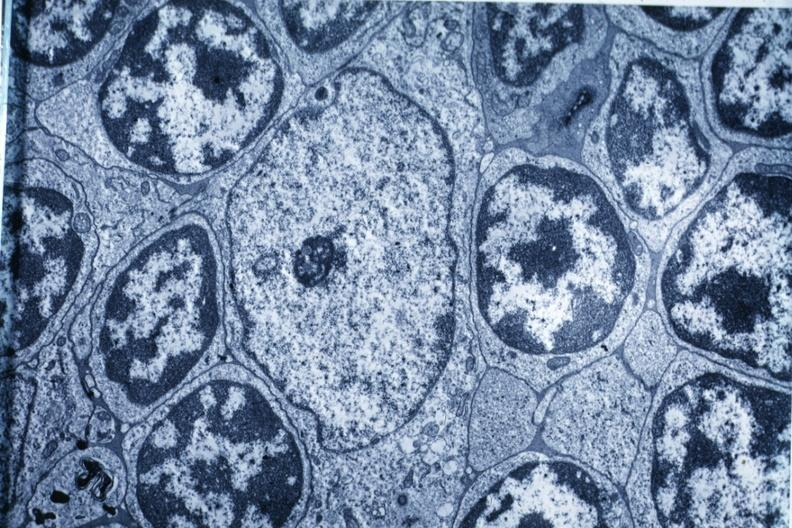s cranial artery present?
Answer the question using a single word or phrase. No 